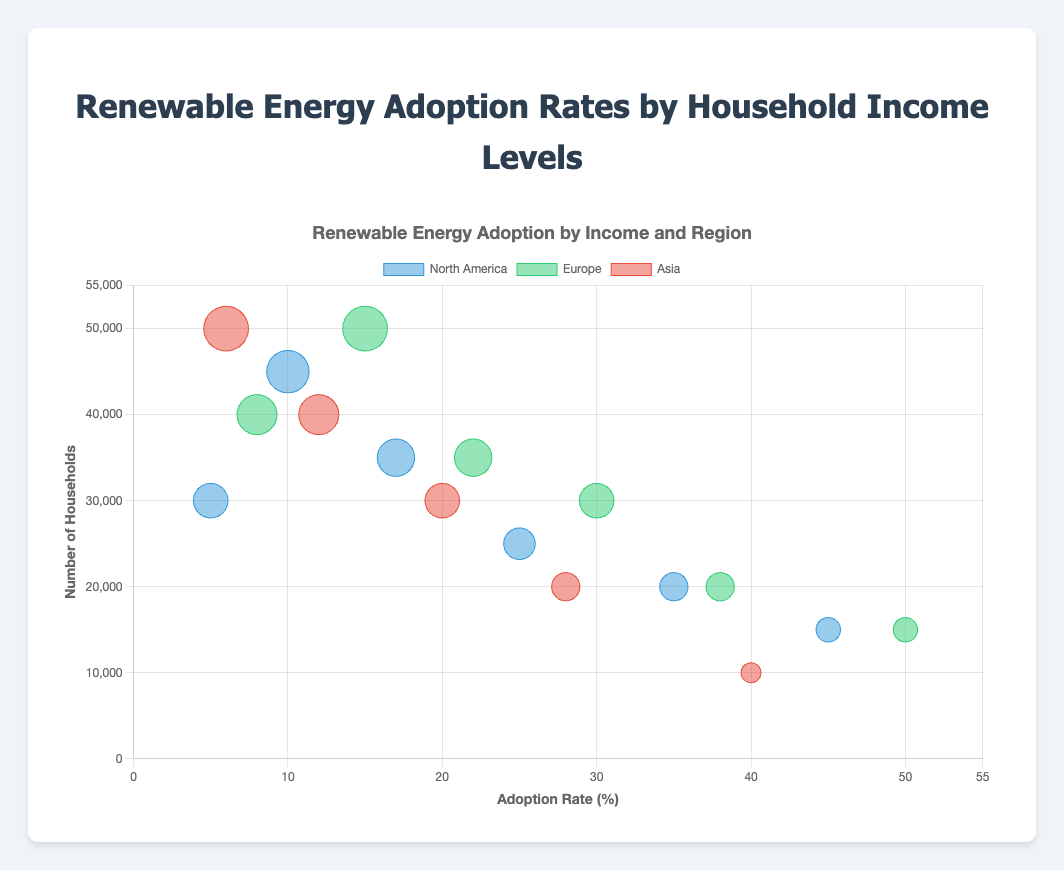What is the title of the chart? The title can be found at the top center of the chart in large, bold text. It reads "Renewable Energy Adoption by Income and Region".
Answer: Renewable Energy Adoption by Income and Region What do the colors in the bubbles represent? The legend at the top of the chart shows that different colors are used for different regions: North America is blue, Europe is green, and Asia is red.
Answer: Regions Which income bracket in Europe has the highest renewable energy adoption rate? The chart's tooltips show details for each bubble when hovered over. For Europe, the highest adoption rate is shown for "Above £100,000" with a rate of 50%.
Answer: Above £100,000 How many households are in the income bracket "$50,000 - $75,000" in North America? Hovering over the bubble for "$50,000 - $75,000" in North America reveals the tooltip, which shows that there are 35,000 households.
Answer: 35,000 Which region has the lowest adoption rate for the "Above ¥20,000,000" income bracket? By comparing the bubbles in each region for the "Above ¥20,000,000" bracket, the tooltip and bubble size show that Asia has the lowest adoption rate of 40%.
Answer: Asia Is there a correlation between income levels and renewable energy adoption rates in North America? Examining the North America bubbles from lowest to highest income, there is a clear upward trend in the adoption rate as income increases, indicating a positive correlation.
Answer: Positive correlation What's the total number of households represented in the income brackets for Europe? Summing up all the household numbers for each income bracket in Europe: 40,000 + 50,000 + 35,000 + 30,000 + 20,000 + 15,000 = 190,000 households.
Answer: 190,000 Compare the adoption rate differences between the highest and lowest income brackets in North America. The highest income bracket in North America ("Above $150,000") has an adoption rate of 45%, while the lowest ("Below $25,000") has 5%. The difference is 45% - 5% = 40%.
Answer: 40% Which region shows the highest adoption rate for the lowest income bracket? Observing the bubbles for the lowest income brackets in each region, the tooltip shows Europe ("Below £20,000") has the highest at 8%.
Answer: Europe Do any regions have an income bracket with exactly a 30% adoption rate? Looking closely, Europe has a bubble for the "£60,000 - £80,000" bracket with a 30% adoption rate. Checking tooltips confirms this.
Answer: Europe 